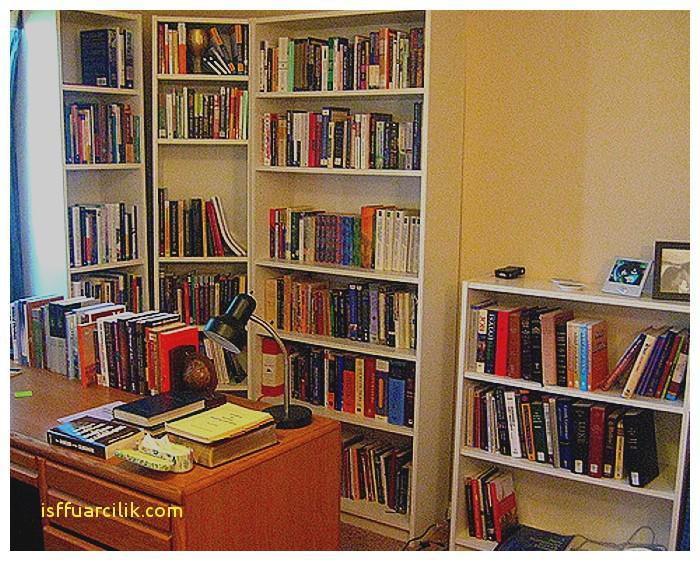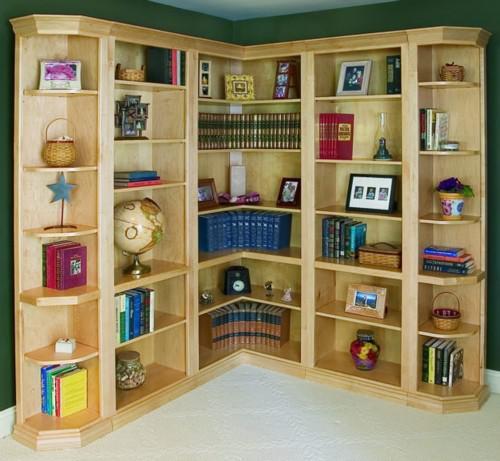The first image is the image on the left, the second image is the image on the right. For the images shown, is this caption "There is a desk in front of the bookcases in one of the images." true? Answer yes or no. Yes. 